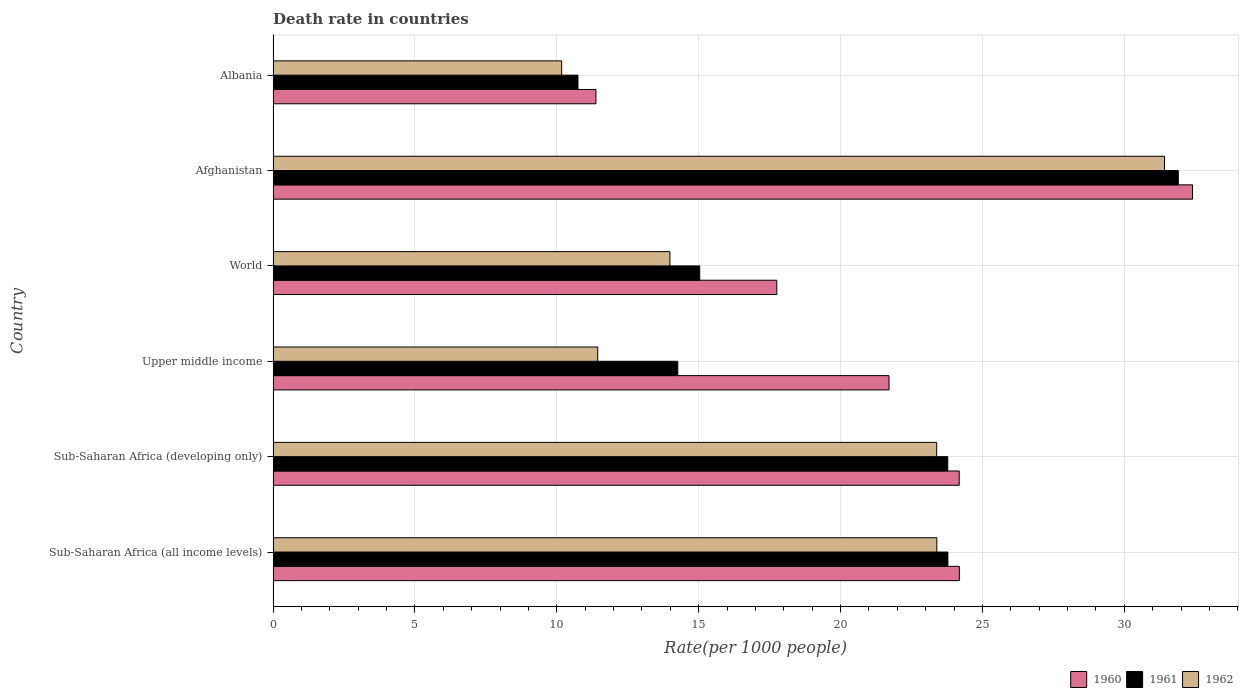Are the number of bars on each tick of the Y-axis equal?
Make the answer very short. Yes. How many bars are there on the 6th tick from the bottom?
Offer a terse response. 3. What is the label of the 5th group of bars from the top?
Offer a very short reply. Sub-Saharan Africa (developing only). What is the death rate in 1960 in Sub-Saharan Africa (developing only)?
Provide a short and direct response. 24.18. Across all countries, what is the maximum death rate in 1961?
Provide a succinct answer. 31.9. Across all countries, what is the minimum death rate in 1961?
Provide a short and direct response. 10.74. In which country was the death rate in 1961 maximum?
Provide a succinct answer. Afghanistan. In which country was the death rate in 1960 minimum?
Keep it short and to the point. Albania. What is the total death rate in 1962 in the graph?
Make the answer very short. 113.79. What is the difference between the death rate in 1961 in Afghanistan and that in Albania?
Your response must be concise. 21.16. What is the difference between the death rate in 1960 in Sub-Saharan Africa (all income levels) and the death rate in 1962 in World?
Give a very brief answer. 10.2. What is the average death rate in 1962 per country?
Give a very brief answer. 18.96. What is the difference between the death rate in 1960 and death rate in 1961 in Albania?
Ensure brevity in your answer.  0.63. What is the ratio of the death rate in 1961 in Sub-Saharan Africa (all income levels) to that in World?
Provide a short and direct response. 1.58. Is the death rate in 1961 in Albania less than that in Sub-Saharan Africa (developing only)?
Make the answer very short. Yes. What is the difference between the highest and the second highest death rate in 1962?
Keep it short and to the point. 8.02. What is the difference between the highest and the lowest death rate in 1961?
Make the answer very short. 21.16. What does the 3rd bar from the bottom in Albania represents?
Your answer should be compact. 1962. Are all the bars in the graph horizontal?
Give a very brief answer. Yes. What is the difference between two consecutive major ticks on the X-axis?
Your answer should be compact. 5. Does the graph contain grids?
Offer a very short reply. Yes. How many legend labels are there?
Give a very brief answer. 3. How are the legend labels stacked?
Your answer should be very brief. Horizontal. What is the title of the graph?
Your answer should be very brief. Death rate in countries. What is the label or title of the X-axis?
Provide a succinct answer. Rate(per 1000 people). What is the label or title of the Y-axis?
Provide a succinct answer. Country. What is the Rate(per 1000 people) in 1960 in Sub-Saharan Africa (all income levels)?
Provide a short and direct response. 24.18. What is the Rate(per 1000 people) of 1961 in Sub-Saharan Africa (all income levels)?
Your answer should be very brief. 23.78. What is the Rate(per 1000 people) of 1962 in Sub-Saharan Africa (all income levels)?
Make the answer very short. 23.39. What is the Rate(per 1000 people) in 1960 in Sub-Saharan Africa (developing only)?
Provide a short and direct response. 24.18. What is the Rate(per 1000 people) in 1961 in Sub-Saharan Africa (developing only)?
Provide a succinct answer. 23.78. What is the Rate(per 1000 people) of 1962 in Sub-Saharan Africa (developing only)?
Your answer should be compact. 23.39. What is the Rate(per 1000 people) in 1960 in Upper middle income?
Provide a short and direct response. 21.71. What is the Rate(per 1000 people) of 1961 in Upper middle income?
Offer a very short reply. 14.26. What is the Rate(per 1000 people) in 1962 in Upper middle income?
Your answer should be compact. 11.44. What is the Rate(per 1000 people) in 1960 in World?
Keep it short and to the point. 17.75. What is the Rate(per 1000 people) of 1961 in World?
Your answer should be compact. 15.04. What is the Rate(per 1000 people) in 1962 in World?
Your answer should be very brief. 13.98. What is the Rate(per 1000 people) of 1960 in Afghanistan?
Your answer should be compact. 32.4. What is the Rate(per 1000 people) of 1961 in Afghanistan?
Make the answer very short. 31.9. What is the Rate(per 1000 people) in 1962 in Afghanistan?
Your answer should be compact. 31.41. What is the Rate(per 1000 people) of 1960 in Albania?
Provide a succinct answer. 11.38. What is the Rate(per 1000 people) in 1961 in Albania?
Offer a very short reply. 10.74. What is the Rate(per 1000 people) of 1962 in Albania?
Make the answer very short. 10.17. Across all countries, what is the maximum Rate(per 1000 people) in 1960?
Give a very brief answer. 32.4. Across all countries, what is the maximum Rate(per 1000 people) in 1961?
Your response must be concise. 31.9. Across all countries, what is the maximum Rate(per 1000 people) in 1962?
Keep it short and to the point. 31.41. Across all countries, what is the minimum Rate(per 1000 people) of 1960?
Make the answer very short. 11.38. Across all countries, what is the minimum Rate(per 1000 people) in 1961?
Ensure brevity in your answer.  10.74. Across all countries, what is the minimum Rate(per 1000 people) in 1962?
Keep it short and to the point. 10.17. What is the total Rate(per 1000 people) of 1960 in the graph?
Your answer should be compact. 131.6. What is the total Rate(per 1000 people) in 1961 in the graph?
Your answer should be compact. 119.5. What is the total Rate(per 1000 people) in 1962 in the graph?
Your answer should be compact. 113.79. What is the difference between the Rate(per 1000 people) of 1960 in Sub-Saharan Africa (all income levels) and that in Sub-Saharan Africa (developing only)?
Ensure brevity in your answer.  0. What is the difference between the Rate(per 1000 people) of 1961 in Sub-Saharan Africa (all income levels) and that in Sub-Saharan Africa (developing only)?
Your answer should be compact. 0. What is the difference between the Rate(per 1000 people) of 1962 in Sub-Saharan Africa (all income levels) and that in Sub-Saharan Africa (developing only)?
Offer a very short reply. 0. What is the difference between the Rate(per 1000 people) in 1960 in Sub-Saharan Africa (all income levels) and that in Upper middle income?
Ensure brevity in your answer.  2.48. What is the difference between the Rate(per 1000 people) of 1961 in Sub-Saharan Africa (all income levels) and that in Upper middle income?
Offer a very short reply. 9.52. What is the difference between the Rate(per 1000 people) in 1962 in Sub-Saharan Africa (all income levels) and that in Upper middle income?
Provide a succinct answer. 11.95. What is the difference between the Rate(per 1000 people) in 1960 in Sub-Saharan Africa (all income levels) and that in World?
Your answer should be compact. 6.43. What is the difference between the Rate(per 1000 people) in 1961 in Sub-Saharan Africa (all income levels) and that in World?
Ensure brevity in your answer.  8.75. What is the difference between the Rate(per 1000 people) in 1962 in Sub-Saharan Africa (all income levels) and that in World?
Your answer should be compact. 9.41. What is the difference between the Rate(per 1000 people) of 1960 in Sub-Saharan Africa (all income levels) and that in Afghanistan?
Keep it short and to the point. -8.22. What is the difference between the Rate(per 1000 people) in 1961 in Sub-Saharan Africa (all income levels) and that in Afghanistan?
Your response must be concise. -8.12. What is the difference between the Rate(per 1000 people) of 1962 in Sub-Saharan Africa (all income levels) and that in Afghanistan?
Provide a succinct answer. -8.02. What is the difference between the Rate(per 1000 people) in 1960 in Sub-Saharan Africa (all income levels) and that in Albania?
Your answer should be compact. 12.81. What is the difference between the Rate(per 1000 people) of 1961 in Sub-Saharan Africa (all income levels) and that in Albania?
Keep it short and to the point. 13.04. What is the difference between the Rate(per 1000 people) of 1962 in Sub-Saharan Africa (all income levels) and that in Albania?
Give a very brief answer. 13.22. What is the difference between the Rate(per 1000 people) of 1960 in Sub-Saharan Africa (developing only) and that in Upper middle income?
Provide a succinct answer. 2.47. What is the difference between the Rate(per 1000 people) in 1961 in Sub-Saharan Africa (developing only) and that in Upper middle income?
Give a very brief answer. 9.52. What is the difference between the Rate(per 1000 people) in 1962 in Sub-Saharan Africa (developing only) and that in Upper middle income?
Offer a very short reply. 11.95. What is the difference between the Rate(per 1000 people) of 1960 in Sub-Saharan Africa (developing only) and that in World?
Your answer should be compact. 6.43. What is the difference between the Rate(per 1000 people) in 1961 in Sub-Saharan Africa (developing only) and that in World?
Offer a terse response. 8.74. What is the difference between the Rate(per 1000 people) of 1962 in Sub-Saharan Africa (developing only) and that in World?
Offer a very short reply. 9.4. What is the difference between the Rate(per 1000 people) in 1960 in Sub-Saharan Africa (developing only) and that in Afghanistan?
Your answer should be very brief. -8.22. What is the difference between the Rate(per 1000 people) in 1961 in Sub-Saharan Africa (developing only) and that in Afghanistan?
Offer a very short reply. -8.12. What is the difference between the Rate(per 1000 people) of 1962 in Sub-Saharan Africa (developing only) and that in Afghanistan?
Give a very brief answer. -8.03. What is the difference between the Rate(per 1000 people) of 1960 in Sub-Saharan Africa (developing only) and that in Albania?
Give a very brief answer. 12.8. What is the difference between the Rate(per 1000 people) in 1961 in Sub-Saharan Africa (developing only) and that in Albania?
Offer a very short reply. 13.03. What is the difference between the Rate(per 1000 people) in 1962 in Sub-Saharan Africa (developing only) and that in Albania?
Provide a short and direct response. 13.22. What is the difference between the Rate(per 1000 people) of 1960 in Upper middle income and that in World?
Make the answer very short. 3.96. What is the difference between the Rate(per 1000 people) of 1961 in Upper middle income and that in World?
Your answer should be very brief. -0.77. What is the difference between the Rate(per 1000 people) of 1962 in Upper middle income and that in World?
Ensure brevity in your answer.  -2.54. What is the difference between the Rate(per 1000 people) in 1960 in Upper middle income and that in Afghanistan?
Make the answer very short. -10.7. What is the difference between the Rate(per 1000 people) in 1961 in Upper middle income and that in Afghanistan?
Your response must be concise. -17.64. What is the difference between the Rate(per 1000 people) in 1962 in Upper middle income and that in Afghanistan?
Provide a short and direct response. -19.98. What is the difference between the Rate(per 1000 people) in 1960 in Upper middle income and that in Albania?
Your answer should be compact. 10.33. What is the difference between the Rate(per 1000 people) in 1961 in Upper middle income and that in Albania?
Provide a succinct answer. 3.52. What is the difference between the Rate(per 1000 people) in 1962 in Upper middle income and that in Albania?
Offer a very short reply. 1.27. What is the difference between the Rate(per 1000 people) of 1960 in World and that in Afghanistan?
Provide a succinct answer. -14.65. What is the difference between the Rate(per 1000 people) of 1961 in World and that in Afghanistan?
Provide a succinct answer. -16.87. What is the difference between the Rate(per 1000 people) of 1962 in World and that in Afghanistan?
Make the answer very short. -17.43. What is the difference between the Rate(per 1000 people) in 1960 in World and that in Albania?
Keep it short and to the point. 6.37. What is the difference between the Rate(per 1000 people) in 1961 in World and that in Albania?
Your answer should be compact. 4.29. What is the difference between the Rate(per 1000 people) of 1962 in World and that in Albania?
Ensure brevity in your answer.  3.82. What is the difference between the Rate(per 1000 people) in 1960 in Afghanistan and that in Albania?
Provide a short and direct response. 21.03. What is the difference between the Rate(per 1000 people) of 1961 in Afghanistan and that in Albania?
Your answer should be compact. 21.16. What is the difference between the Rate(per 1000 people) of 1962 in Afghanistan and that in Albania?
Give a very brief answer. 21.25. What is the difference between the Rate(per 1000 people) of 1960 in Sub-Saharan Africa (all income levels) and the Rate(per 1000 people) of 1961 in Sub-Saharan Africa (developing only)?
Offer a terse response. 0.41. What is the difference between the Rate(per 1000 people) of 1960 in Sub-Saharan Africa (all income levels) and the Rate(per 1000 people) of 1962 in Sub-Saharan Africa (developing only)?
Offer a terse response. 0.8. What is the difference between the Rate(per 1000 people) of 1961 in Sub-Saharan Africa (all income levels) and the Rate(per 1000 people) of 1962 in Sub-Saharan Africa (developing only)?
Your answer should be very brief. 0.39. What is the difference between the Rate(per 1000 people) in 1960 in Sub-Saharan Africa (all income levels) and the Rate(per 1000 people) in 1961 in Upper middle income?
Offer a very short reply. 9.92. What is the difference between the Rate(per 1000 people) of 1960 in Sub-Saharan Africa (all income levels) and the Rate(per 1000 people) of 1962 in Upper middle income?
Your answer should be compact. 12.75. What is the difference between the Rate(per 1000 people) in 1961 in Sub-Saharan Africa (all income levels) and the Rate(per 1000 people) in 1962 in Upper middle income?
Provide a succinct answer. 12.34. What is the difference between the Rate(per 1000 people) of 1960 in Sub-Saharan Africa (all income levels) and the Rate(per 1000 people) of 1961 in World?
Provide a short and direct response. 9.15. What is the difference between the Rate(per 1000 people) of 1960 in Sub-Saharan Africa (all income levels) and the Rate(per 1000 people) of 1962 in World?
Make the answer very short. 10.2. What is the difference between the Rate(per 1000 people) in 1961 in Sub-Saharan Africa (all income levels) and the Rate(per 1000 people) in 1962 in World?
Offer a very short reply. 9.8. What is the difference between the Rate(per 1000 people) of 1960 in Sub-Saharan Africa (all income levels) and the Rate(per 1000 people) of 1961 in Afghanistan?
Your answer should be compact. -7.72. What is the difference between the Rate(per 1000 people) of 1960 in Sub-Saharan Africa (all income levels) and the Rate(per 1000 people) of 1962 in Afghanistan?
Your response must be concise. -7.23. What is the difference between the Rate(per 1000 people) of 1961 in Sub-Saharan Africa (all income levels) and the Rate(per 1000 people) of 1962 in Afghanistan?
Provide a short and direct response. -7.63. What is the difference between the Rate(per 1000 people) of 1960 in Sub-Saharan Africa (all income levels) and the Rate(per 1000 people) of 1961 in Albania?
Offer a terse response. 13.44. What is the difference between the Rate(per 1000 people) of 1960 in Sub-Saharan Africa (all income levels) and the Rate(per 1000 people) of 1962 in Albania?
Provide a succinct answer. 14.02. What is the difference between the Rate(per 1000 people) in 1961 in Sub-Saharan Africa (all income levels) and the Rate(per 1000 people) in 1962 in Albania?
Provide a short and direct response. 13.61. What is the difference between the Rate(per 1000 people) in 1960 in Sub-Saharan Africa (developing only) and the Rate(per 1000 people) in 1961 in Upper middle income?
Your answer should be compact. 9.92. What is the difference between the Rate(per 1000 people) of 1960 in Sub-Saharan Africa (developing only) and the Rate(per 1000 people) of 1962 in Upper middle income?
Provide a succinct answer. 12.74. What is the difference between the Rate(per 1000 people) of 1961 in Sub-Saharan Africa (developing only) and the Rate(per 1000 people) of 1962 in Upper middle income?
Provide a succinct answer. 12.34. What is the difference between the Rate(per 1000 people) of 1960 in Sub-Saharan Africa (developing only) and the Rate(per 1000 people) of 1961 in World?
Ensure brevity in your answer.  9.15. What is the difference between the Rate(per 1000 people) of 1960 in Sub-Saharan Africa (developing only) and the Rate(per 1000 people) of 1962 in World?
Provide a short and direct response. 10.2. What is the difference between the Rate(per 1000 people) of 1961 in Sub-Saharan Africa (developing only) and the Rate(per 1000 people) of 1962 in World?
Provide a short and direct response. 9.79. What is the difference between the Rate(per 1000 people) of 1960 in Sub-Saharan Africa (developing only) and the Rate(per 1000 people) of 1961 in Afghanistan?
Keep it short and to the point. -7.72. What is the difference between the Rate(per 1000 people) in 1960 in Sub-Saharan Africa (developing only) and the Rate(per 1000 people) in 1962 in Afghanistan?
Offer a very short reply. -7.23. What is the difference between the Rate(per 1000 people) in 1961 in Sub-Saharan Africa (developing only) and the Rate(per 1000 people) in 1962 in Afghanistan?
Offer a very short reply. -7.64. What is the difference between the Rate(per 1000 people) in 1960 in Sub-Saharan Africa (developing only) and the Rate(per 1000 people) in 1961 in Albania?
Give a very brief answer. 13.44. What is the difference between the Rate(per 1000 people) of 1960 in Sub-Saharan Africa (developing only) and the Rate(per 1000 people) of 1962 in Albania?
Provide a succinct answer. 14.01. What is the difference between the Rate(per 1000 people) of 1961 in Sub-Saharan Africa (developing only) and the Rate(per 1000 people) of 1962 in Albania?
Give a very brief answer. 13.61. What is the difference between the Rate(per 1000 people) in 1960 in Upper middle income and the Rate(per 1000 people) in 1961 in World?
Your response must be concise. 6.67. What is the difference between the Rate(per 1000 people) of 1960 in Upper middle income and the Rate(per 1000 people) of 1962 in World?
Make the answer very short. 7.72. What is the difference between the Rate(per 1000 people) in 1961 in Upper middle income and the Rate(per 1000 people) in 1962 in World?
Offer a terse response. 0.28. What is the difference between the Rate(per 1000 people) of 1960 in Upper middle income and the Rate(per 1000 people) of 1961 in Afghanistan?
Make the answer very short. -10.19. What is the difference between the Rate(per 1000 people) of 1960 in Upper middle income and the Rate(per 1000 people) of 1962 in Afghanistan?
Your answer should be very brief. -9.71. What is the difference between the Rate(per 1000 people) of 1961 in Upper middle income and the Rate(per 1000 people) of 1962 in Afghanistan?
Your response must be concise. -17.15. What is the difference between the Rate(per 1000 people) in 1960 in Upper middle income and the Rate(per 1000 people) in 1961 in Albania?
Your answer should be compact. 10.96. What is the difference between the Rate(per 1000 people) in 1960 in Upper middle income and the Rate(per 1000 people) in 1962 in Albania?
Your response must be concise. 11.54. What is the difference between the Rate(per 1000 people) of 1961 in Upper middle income and the Rate(per 1000 people) of 1962 in Albania?
Make the answer very short. 4.09. What is the difference between the Rate(per 1000 people) in 1960 in World and the Rate(per 1000 people) in 1961 in Afghanistan?
Your answer should be very brief. -14.15. What is the difference between the Rate(per 1000 people) of 1960 in World and the Rate(per 1000 people) of 1962 in Afghanistan?
Ensure brevity in your answer.  -13.66. What is the difference between the Rate(per 1000 people) in 1961 in World and the Rate(per 1000 people) in 1962 in Afghanistan?
Your answer should be very brief. -16.38. What is the difference between the Rate(per 1000 people) in 1960 in World and the Rate(per 1000 people) in 1961 in Albania?
Make the answer very short. 7.01. What is the difference between the Rate(per 1000 people) in 1960 in World and the Rate(per 1000 people) in 1962 in Albania?
Ensure brevity in your answer.  7.58. What is the difference between the Rate(per 1000 people) in 1961 in World and the Rate(per 1000 people) in 1962 in Albania?
Provide a succinct answer. 4.87. What is the difference between the Rate(per 1000 people) in 1960 in Afghanistan and the Rate(per 1000 people) in 1961 in Albania?
Your response must be concise. 21.66. What is the difference between the Rate(per 1000 people) in 1960 in Afghanistan and the Rate(per 1000 people) in 1962 in Albania?
Your answer should be compact. 22.23. What is the difference between the Rate(per 1000 people) of 1961 in Afghanistan and the Rate(per 1000 people) of 1962 in Albania?
Provide a succinct answer. 21.73. What is the average Rate(per 1000 people) of 1960 per country?
Give a very brief answer. 21.93. What is the average Rate(per 1000 people) in 1961 per country?
Offer a very short reply. 19.92. What is the average Rate(per 1000 people) of 1962 per country?
Your answer should be compact. 18.96. What is the difference between the Rate(per 1000 people) of 1960 and Rate(per 1000 people) of 1961 in Sub-Saharan Africa (all income levels)?
Provide a short and direct response. 0.4. What is the difference between the Rate(per 1000 people) of 1960 and Rate(per 1000 people) of 1962 in Sub-Saharan Africa (all income levels)?
Give a very brief answer. 0.79. What is the difference between the Rate(per 1000 people) of 1961 and Rate(per 1000 people) of 1962 in Sub-Saharan Africa (all income levels)?
Your response must be concise. 0.39. What is the difference between the Rate(per 1000 people) of 1960 and Rate(per 1000 people) of 1961 in Sub-Saharan Africa (developing only)?
Offer a terse response. 0.4. What is the difference between the Rate(per 1000 people) of 1960 and Rate(per 1000 people) of 1962 in Sub-Saharan Africa (developing only)?
Offer a terse response. 0.79. What is the difference between the Rate(per 1000 people) of 1961 and Rate(per 1000 people) of 1962 in Sub-Saharan Africa (developing only)?
Your answer should be very brief. 0.39. What is the difference between the Rate(per 1000 people) in 1960 and Rate(per 1000 people) in 1961 in Upper middle income?
Provide a short and direct response. 7.45. What is the difference between the Rate(per 1000 people) of 1960 and Rate(per 1000 people) of 1962 in Upper middle income?
Ensure brevity in your answer.  10.27. What is the difference between the Rate(per 1000 people) of 1961 and Rate(per 1000 people) of 1962 in Upper middle income?
Ensure brevity in your answer.  2.82. What is the difference between the Rate(per 1000 people) in 1960 and Rate(per 1000 people) in 1961 in World?
Your answer should be very brief. 2.72. What is the difference between the Rate(per 1000 people) in 1960 and Rate(per 1000 people) in 1962 in World?
Provide a short and direct response. 3.77. What is the difference between the Rate(per 1000 people) of 1961 and Rate(per 1000 people) of 1962 in World?
Offer a terse response. 1.05. What is the difference between the Rate(per 1000 people) of 1960 and Rate(per 1000 people) of 1961 in Afghanistan?
Provide a short and direct response. 0.5. What is the difference between the Rate(per 1000 people) in 1960 and Rate(per 1000 people) in 1962 in Afghanistan?
Keep it short and to the point. 0.99. What is the difference between the Rate(per 1000 people) in 1961 and Rate(per 1000 people) in 1962 in Afghanistan?
Your response must be concise. 0.49. What is the difference between the Rate(per 1000 people) in 1960 and Rate(per 1000 people) in 1961 in Albania?
Ensure brevity in your answer.  0.63. What is the difference between the Rate(per 1000 people) in 1960 and Rate(per 1000 people) in 1962 in Albania?
Offer a very short reply. 1.21. What is the difference between the Rate(per 1000 people) in 1961 and Rate(per 1000 people) in 1962 in Albania?
Offer a very short reply. 0.57. What is the ratio of the Rate(per 1000 people) of 1960 in Sub-Saharan Africa (all income levels) to that in Upper middle income?
Your response must be concise. 1.11. What is the ratio of the Rate(per 1000 people) of 1961 in Sub-Saharan Africa (all income levels) to that in Upper middle income?
Provide a short and direct response. 1.67. What is the ratio of the Rate(per 1000 people) of 1962 in Sub-Saharan Africa (all income levels) to that in Upper middle income?
Provide a succinct answer. 2.04. What is the ratio of the Rate(per 1000 people) in 1960 in Sub-Saharan Africa (all income levels) to that in World?
Your response must be concise. 1.36. What is the ratio of the Rate(per 1000 people) of 1961 in Sub-Saharan Africa (all income levels) to that in World?
Give a very brief answer. 1.58. What is the ratio of the Rate(per 1000 people) of 1962 in Sub-Saharan Africa (all income levels) to that in World?
Your answer should be compact. 1.67. What is the ratio of the Rate(per 1000 people) in 1960 in Sub-Saharan Africa (all income levels) to that in Afghanistan?
Ensure brevity in your answer.  0.75. What is the ratio of the Rate(per 1000 people) in 1961 in Sub-Saharan Africa (all income levels) to that in Afghanistan?
Offer a terse response. 0.75. What is the ratio of the Rate(per 1000 people) in 1962 in Sub-Saharan Africa (all income levels) to that in Afghanistan?
Offer a terse response. 0.74. What is the ratio of the Rate(per 1000 people) in 1960 in Sub-Saharan Africa (all income levels) to that in Albania?
Your answer should be very brief. 2.13. What is the ratio of the Rate(per 1000 people) of 1961 in Sub-Saharan Africa (all income levels) to that in Albania?
Give a very brief answer. 2.21. What is the ratio of the Rate(per 1000 people) of 1962 in Sub-Saharan Africa (all income levels) to that in Albania?
Provide a short and direct response. 2.3. What is the ratio of the Rate(per 1000 people) of 1960 in Sub-Saharan Africa (developing only) to that in Upper middle income?
Keep it short and to the point. 1.11. What is the ratio of the Rate(per 1000 people) in 1961 in Sub-Saharan Africa (developing only) to that in Upper middle income?
Ensure brevity in your answer.  1.67. What is the ratio of the Rate(per 1000 people) in 1962 in Sub-Saharan Africa (developing only) to that in Upper middle income?
Offer a very short reply. 2.04. What is the ratio of the Rate(per 1000 people) of 1960 in Sub-Saharan Africa (developing only) to that in World?
Make the answer very short. 1.36. What is the ratio of the Rate(per 1000 people) of 1961 in Sub-Saharan Africa (developing only) to that in World?
Ensure brevity in your answer.  1.58. What is the ratio of the Rate(per 1000 people) of 1962 in Sub-Saharan Africa (developing only) to that in World?
Your answer should be very brief. 1.67. What is the ratio of the Rate(per 1000 people) of 1960 in Sub-Saharan Africa (developing only) to that in Afghanistan?
Ensure brevity in your answer.  0.75. What is the ratio of the Rate(per 1000 people) in 1961 in Sub-Saharan Africa (developing only) to that in Afghanistan?
Your response must be concise. 0.75. What is the ratio of the Rate(per 1000 people) of 1962 in Sub-Saharan Africa (developing only) to that in Afghanistan?
Your response must be concise. 0.74. What is the ratio of the Rate(per 1000 people) in 1960 in Sub-Saharan Africa (developing only) to that in Albania?
Your answer should be compact. 2.13. What is the ratio of the Rate(per 1000 people) of 1961 in Sub-Saharan Africa (developing only) to that in Albania?
Make the answer very short. 2.21. What is the ratio of the Rate(per 1000 people) in 1962 in Sub-Saharan Africa (developing only) to that in Albania?
Provide a short and direct response. 2.3. What is the ratio of the Rate(per 1000 people) in 1960 in Upper middle income to that in World?
Offer a very short reply. 1.22. What is the ratio of the Rate(per 1000 people) of 1961 in Upper middle income to that in World?
Give a very brief answer. 0.95. What is the ratio of the Rate(per 1000 people) of 1962 in Upper middle income to that in World?
Make the answer very short. 0.82. What is the ratio of the Rate(per 1000 people) of 1960 in Upper middle income to that in Afghanistan?
Provide a succinct answer. 0.67. What is the ratio of the Rate(per 1000 people) of 1961 in Upper middle income to that in Afghanistan?
Keep it short and to the point. 0.45. What is the ratio of the Rate(per 1000 people) in 1962 in Upper middle income to that in Afghanistan?
Provide a short and direct response. 0.36. What is the ratio of the Rate(per 1000 people) of 1960 in Upper middle income to that in Albania?
Your response must be concise. 1.91. What is the ratio of the Rate(per 1000 people) of 1961 in Upper middle income to that in Albania?
Make the answer very short. 1.33. What is the ratio of the Rate(per 1000 people) in 1962 in Upper middle income to that in Albania?
Make the answer very short. 1.12. What is the ratio of the Rate(per 1000 people) of 1960 in World to that in Afghanistan?
Make the answer very short. 0.55. What is the ratio of the Rate(per 1000 people) of 1961 in World to that in Afghanistan?
Offer a terse response. 0.47. What is the ratio of the Rate(per 1000 people) in 1962 in World to that in Afghanistan?
Your answer should be compact. 0.45. What is the ratio of the Rate(per 1000 people) of 1960 in World to that in Albania?
Your answer should be very brief. 1.56. What is the ratio of the Rate(per 1000 people) of 1961 in World to that in Albania?
Provide a succinct answer. 1.4. What is the ratio of the Rate(per 1000 people) of 1962 in World to that in Albania?
Keep it short and to the point. 1.38. What is the ratio of the Rate(per 1000 people) in 1960 in Afghanistan to that in Albania?
Offer a very short reply. 2.85. What is the ratio of the Rate(per 1000 people) in 1961 in Afghanistan to that in Albania?
Ensure brevity in your answer.  2.97. What is the ratio of the Rate(per 1000 people) in 1962 in Afghanistan to that in Albania?
Provide a succinct answer. 3.09. What is the difference between the highest and the second highest Rate(per 1000 people) in 1960?
Offer a very short reply. 8.22. What is the difference between the highest and the second highest Rate(per 1000 people) of 1961?
Offer a terse response. 8.12. What is the difference between the highest and the second highest Rate(per 1000 people) of 1962?
Make the answer very short. 8.02. What is the difference between the highest and the lowest Rate(per 1000 people) of 1960?
Provide a short and direct response. 21.03. What is the difference between the highest and the lowest Rate(per 1000 people) in 1961?
Ensure brevity in your answer.  21.16. What is the difference between the highest and the lowest Rate(per 1000 people) of 1962?
Give a very brief answer. 21.25. 